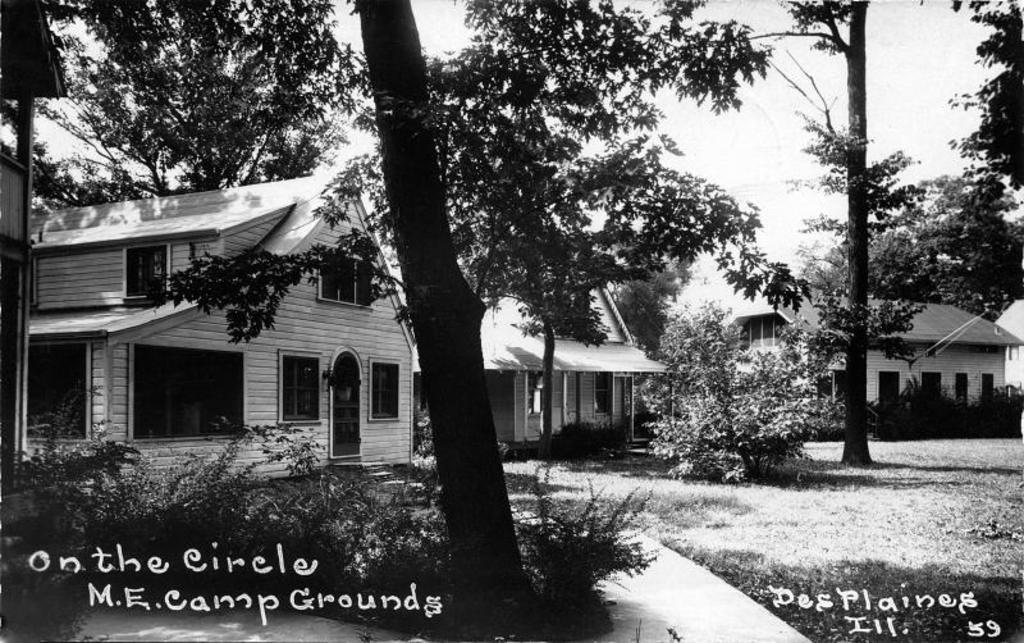What type of structures can be seen in the image? There are houses with windows in the image. What type of vegetation is present in the image? There are trees and grass in the image. What type of surface can be seen in the image? There is a path in the image. What is visible in the background of the image? The sky is visible in the background of the image. Can you describe the body language of the farmer in the image? There is no farmer present in the image; it features houses, trees, grass, a path, and the sky. What type of insect can be seen crawling on the leaves of the trees in the image? There are no insects visible in the image; it only shows houses, trees, grass, a path, and the sky. 